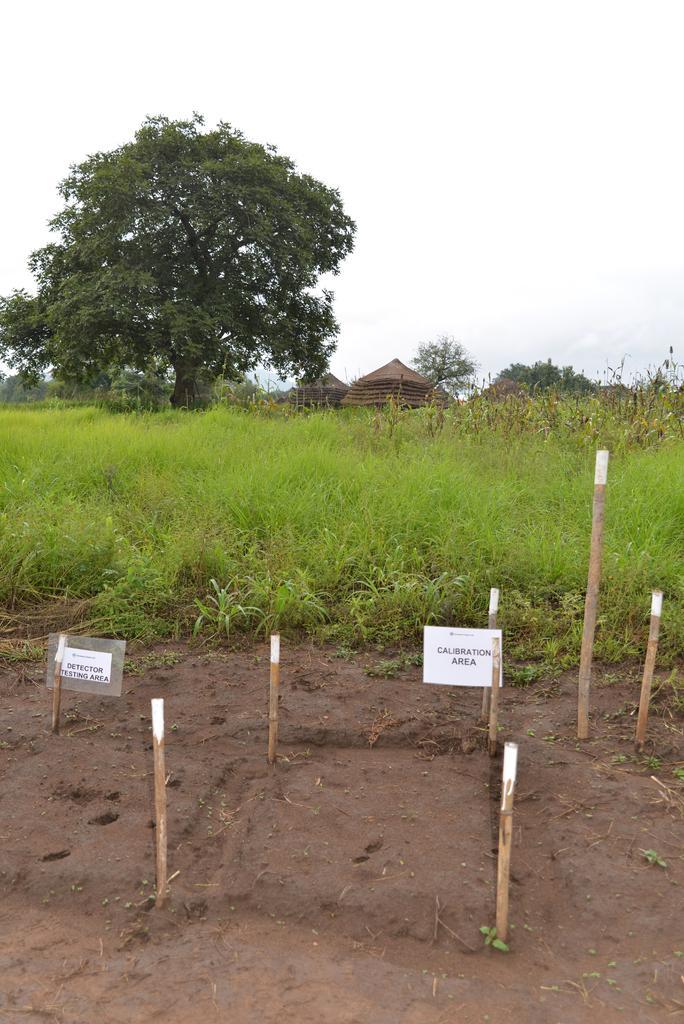Can you describe this image briefly? This picture is clicked outside. In the foreground we can see the bamboo and the boards on which we can see the text. In the center we can see the green grass and in the background there is a sky, trees and some houses. 